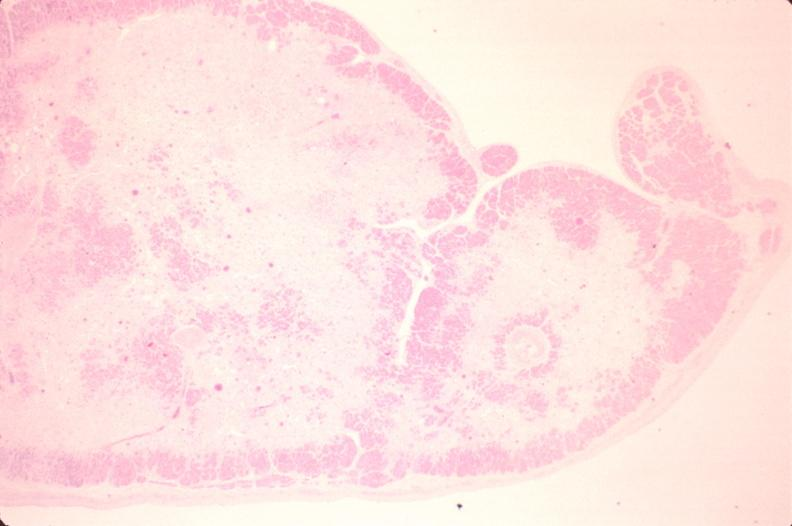what does this image show?
Answer the question using a single word or phrase. Heart 